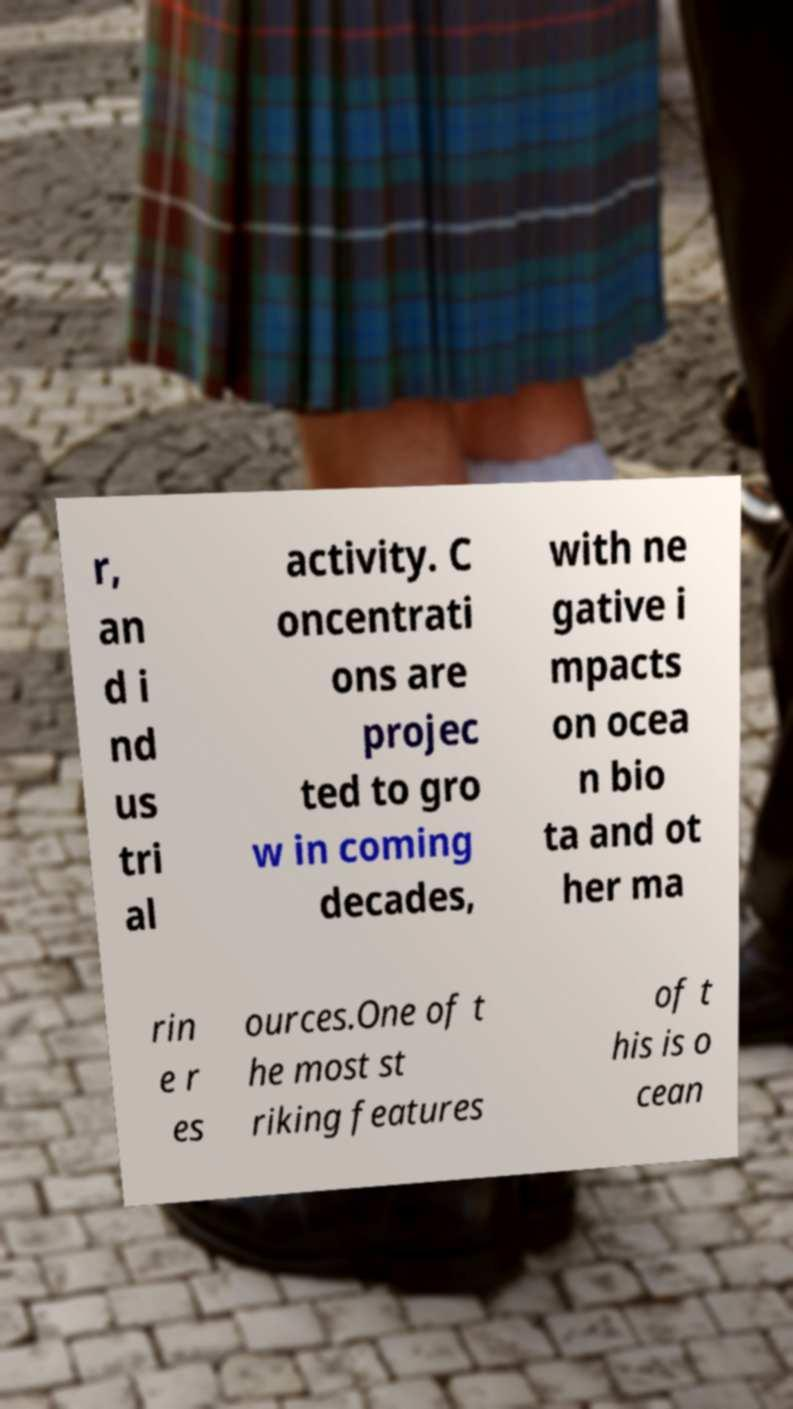Can you read and provide the text displayed in the image?This photo seems to have some interesting text. Can you extract and type it out for me? r, an d i nd us tri al activity. C oncentrati ons are projec ted to gro w in coming decades, with ne gative i mpacts on ocea n bio ta and ot her ma rin e r es ources.One of t he most st riking features of t his is o cean 